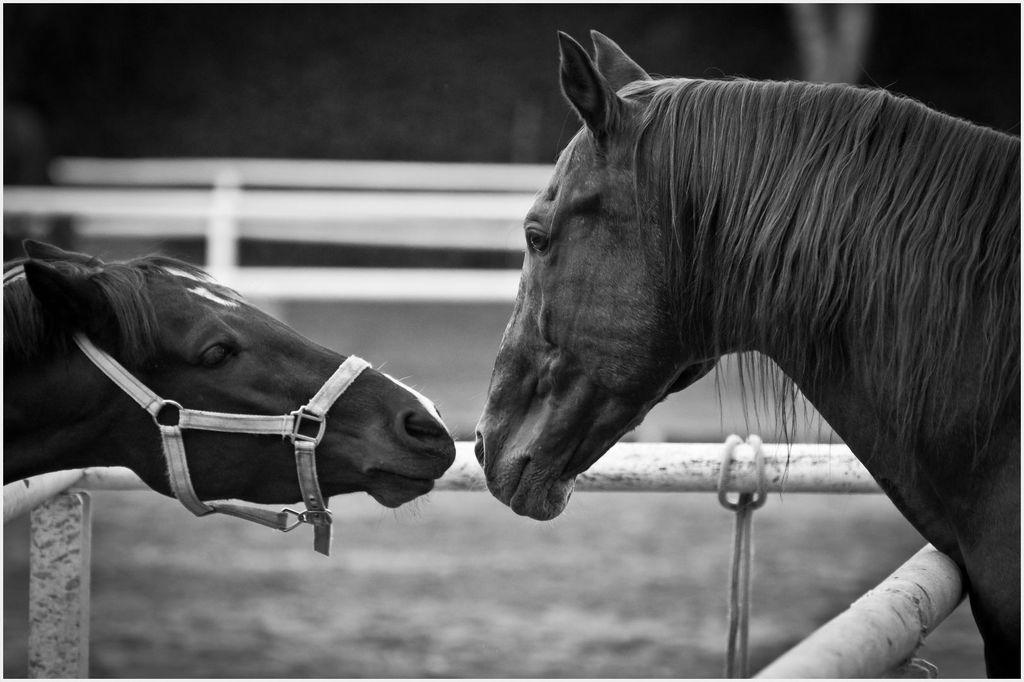What is the color scheme of the image? The image is black and white. How many horses are present in the image? There are two horses in the image. What are the horses doing in the image? The horses are staring at each other. What can be seen at the bottom of the image? There are metal rods at the bottom of the image. How would you describe the background of the image? The background of the image is blurred. What type of hobbies do the horses enjoy in the image? The image does not provide information about the horses' hobbies, as it only shows them staring at each other. Is there any eggnog visible in the image? There is no eggnog present in the image. 